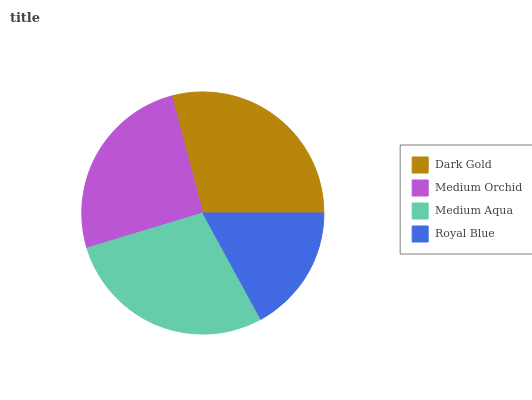Is Royal Blue the minimum?
Answer yes or no. Yes. Is Dark Gold the maximum?
Answer yes or no. Yes. Is Medium Orchid the minimum?
Answer yes or no. No. Is Medium Orchid the maximum?
Answer yes or no. No. Is Dark Gold greater than Medium Orchid?
Answer yes or no. Yes. Is Medium Orchid less than Dark Gold?
Answer yes or no. Yes. Is Medium Orchid greater than Dark Gold?
Answer yes or no. No. Is Dark Gold less than Medium Orchid?
Answer yes or no. No. Is Medium Aqua the high median?
Answer yes or no. Yes. Is Medium Orchid the low median?
Answer yes or no. Yes. Is Royal Blue the high median?
Answer yes or no. No. Is Royal Blue the low median?
Answer yes or no. No. 